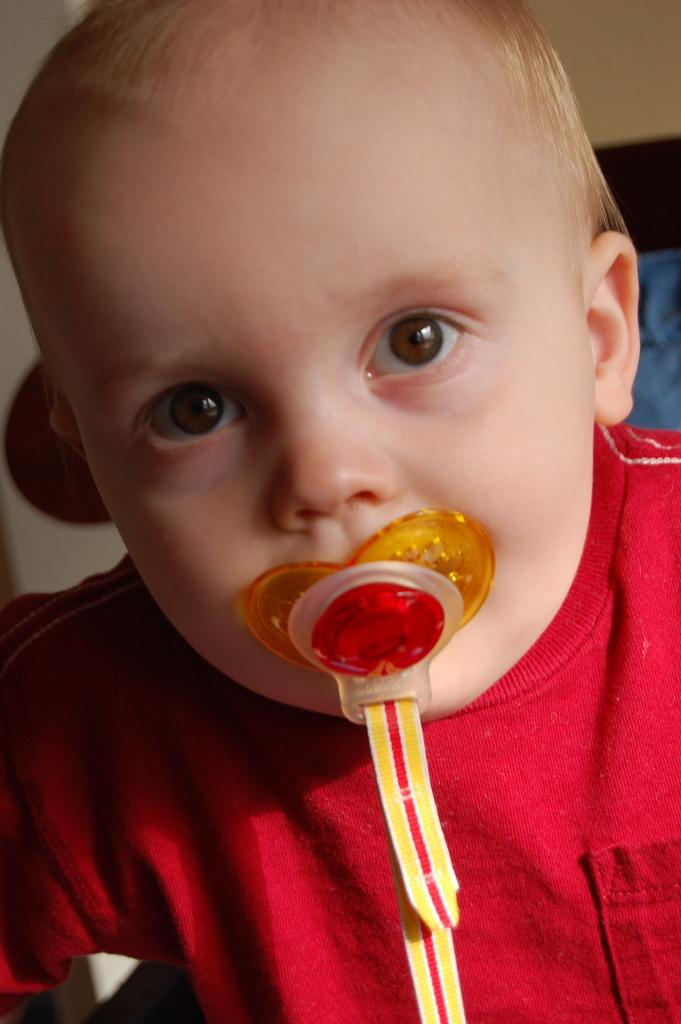What is the main subject of the image? There is a child in the image. What is the child doing in the image? The child has an object in his mouth. What can be seen behind the child in the image? There is a wall visible in the image. What else is present in the background of the image? There are other objects present in the background of the image. What type of bun is the child holding in the image? There is no bun present in the image; the child has an object in his mouth. What arithmetic problem is the child solving in the image? There is no indication of any arithmetic problem in the image; the child is simply holding an object in his mouth. 